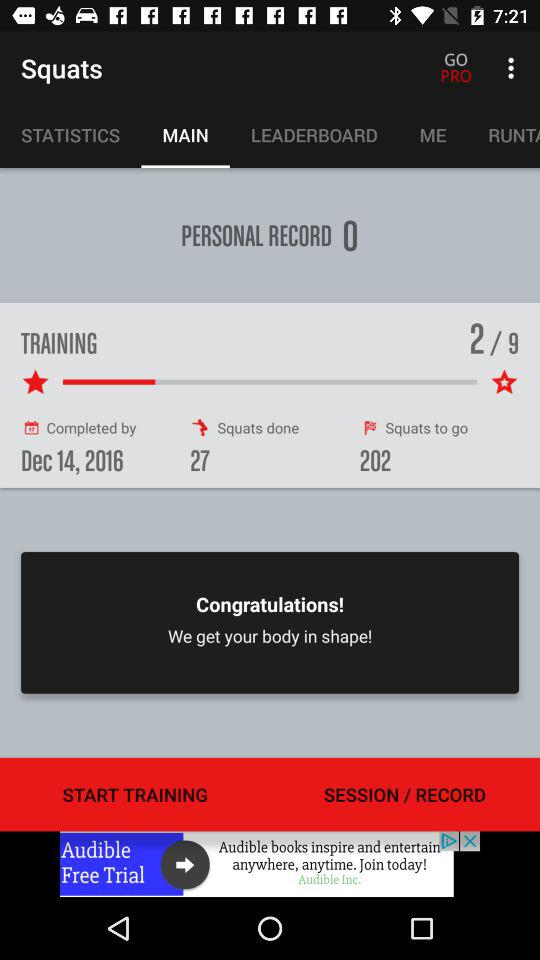How many squats are left? There are 202 squats left. 